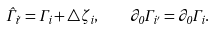<formula> <loc_0><loc_0><loc_500><loc_500>\hat { \Gamma } _ { i ^ { \prime } } = \Gamma _ { i } + \triangle \zeta _ { i } , \quad \partial _ { 0 } \Gamma _ { i ^ { \prime } } = \partial _ { 0 } \Gamma _ { i } .</formula> 